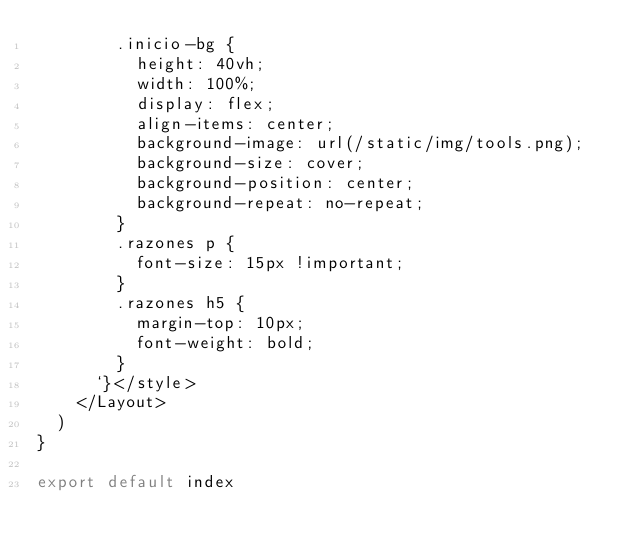Convert code to text. <code><loc_0><loc_0><loc_500><loc_500><_JavaScript_>        .inicio-bg {
          height: 40vh;
          width: 100%;
          display: flex;
          align-items: center;
          background-image: url(/static/img/tools.png);
          background-size: cover;
          background-position: center;
          background-repeat: no-repeat;
        }
        .razones p {
          font-size: 15px !important;
        }
        .razones h5 {
          margin-top: 10px;
          font-weight: bold;
        }
      `}</style>
    </Layout>
  )
}

export default index
</code> 